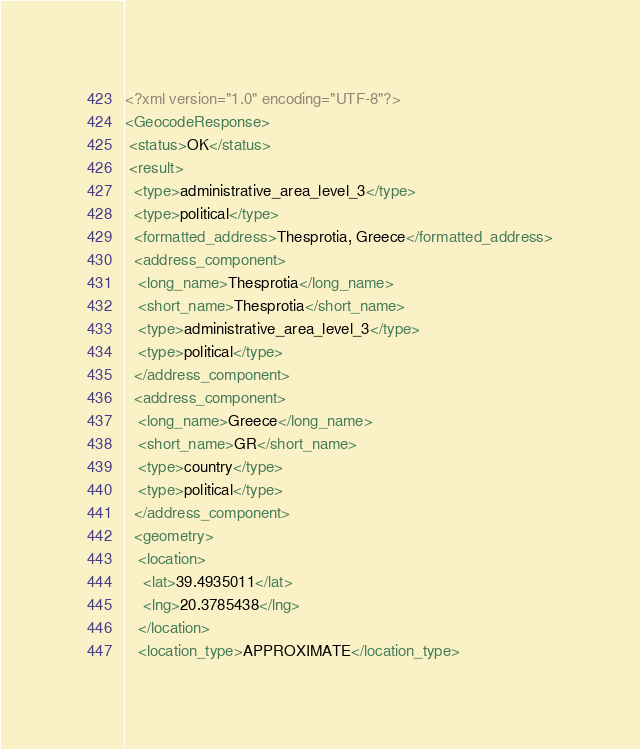<code> <loc_0><loc_0><loc_500><loc_500><_XML_><?xml version="1.0" encoding="UTF-8"?>
<GeocodeResponse>
 <status>OK</status>
 <result>
  <type>administrative_area_level_3</type>
  <type>political</type>
  <formatted_address>Thesprotia, Greece</formatted_address>
  <address_component>
   <long_name>Thesprotia</long_name>
   <short_name>Thesprotia</short_name>
   <type>administrative_area_level_3</type>
   <type>political</type>
  </address_component>
  <address_component>
   <long_name>Greece</long_name>
   <short_name>GR</short_name>
   <type>country</type>
   <type>political</type>
  </address_component>
  <geometry>
   <location>
    <lat>39.4935011</lat>
    <lng>20.3785438</lng>
   </location>
   <location_type>APPROXIMATE</location_type></code> 